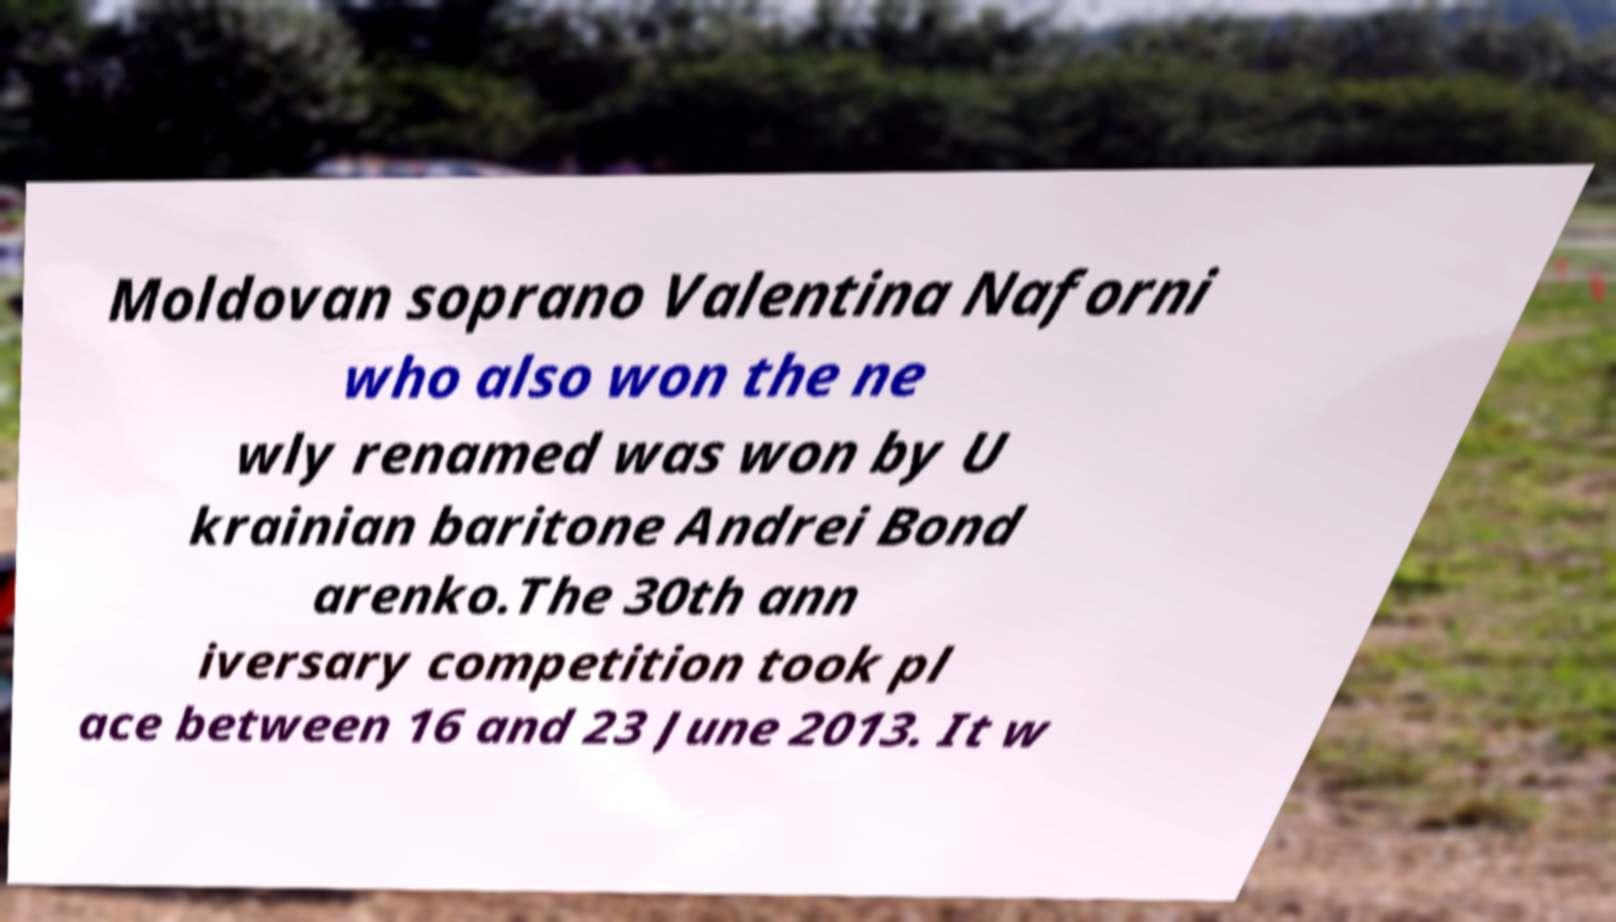Can you accurately transcribe the text from the provided image for me? Moldovan soprano Valentina Naforni who also won the ne wly renamed was won by U krainian baritone Andrei Bond arenko.The 30th ann iversary competition took pl ace between 16 and 23 June 2013. It w 